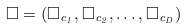Convert formula to latex. <formula><loc_0><loc_0><loc_500><loc_500>\Box = ( \Box _ { c _ { 1 } } , \Box _ { c _ { 2 } } , \dots , \Box _ { c _ { D } } )</formula> 